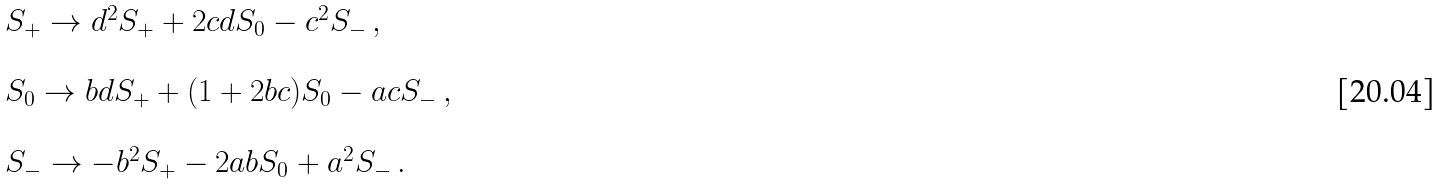<formula> <loc_0><loc_0><loc_500><loc_500>\begin{array} { l } S _ { + } \rightarrow d ^ { 2 } S _ { + } + 2 c d S _ { 0 } - c ^ { 2 } S _ { - } \, , \\ \\ S _ { 0 } \rightarrow b d S _ { + } + ( 1 + 2 b c ) S _ { 0 } - a c S _ { - } \, , \\ \\ S _ { - } \rightarrow - b ^ { 2 } S _ { + } - 2 a b S _ { 0 } + a ^ { 2 } S _ { - } \, . \end{array}</formula> 